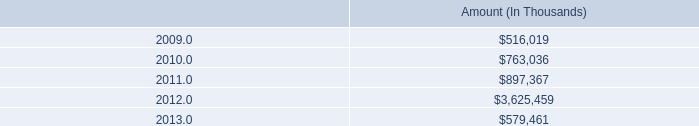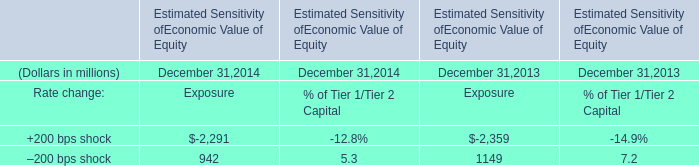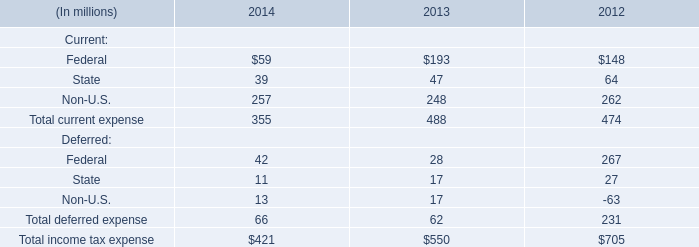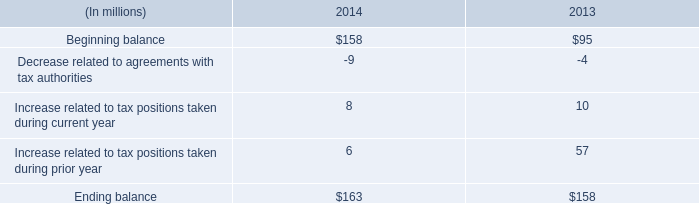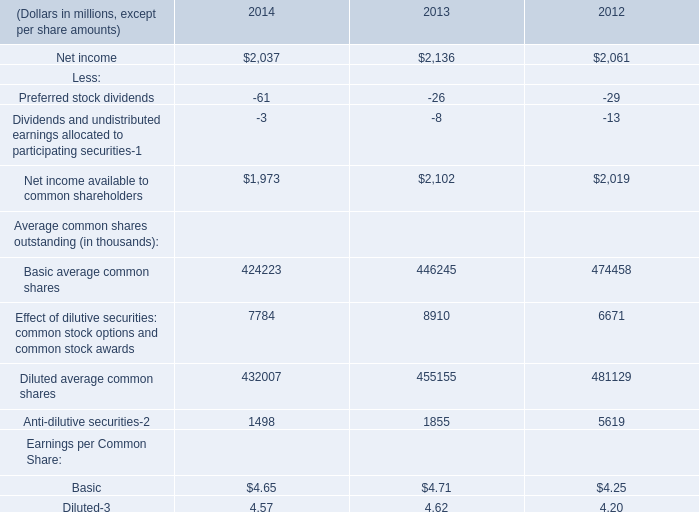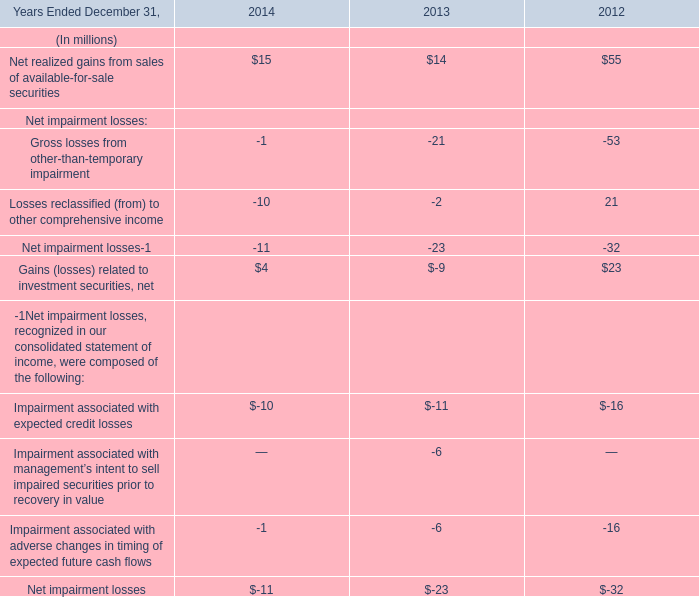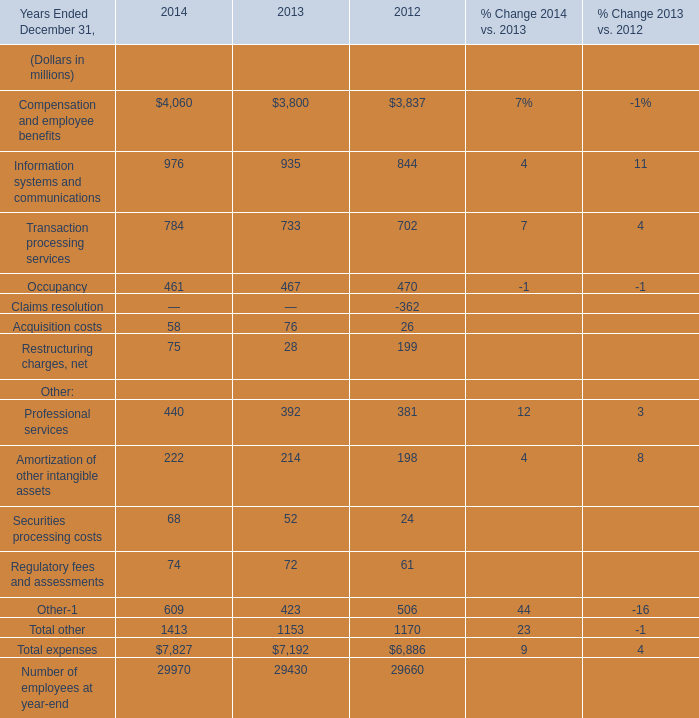If Transaction processing services develops with the same growth rate in 2014, what will it reach in 2015? (in million) 
Computations: (784 * (1 + ((784 - 733) / 733)))
Answer: 838.54843. 